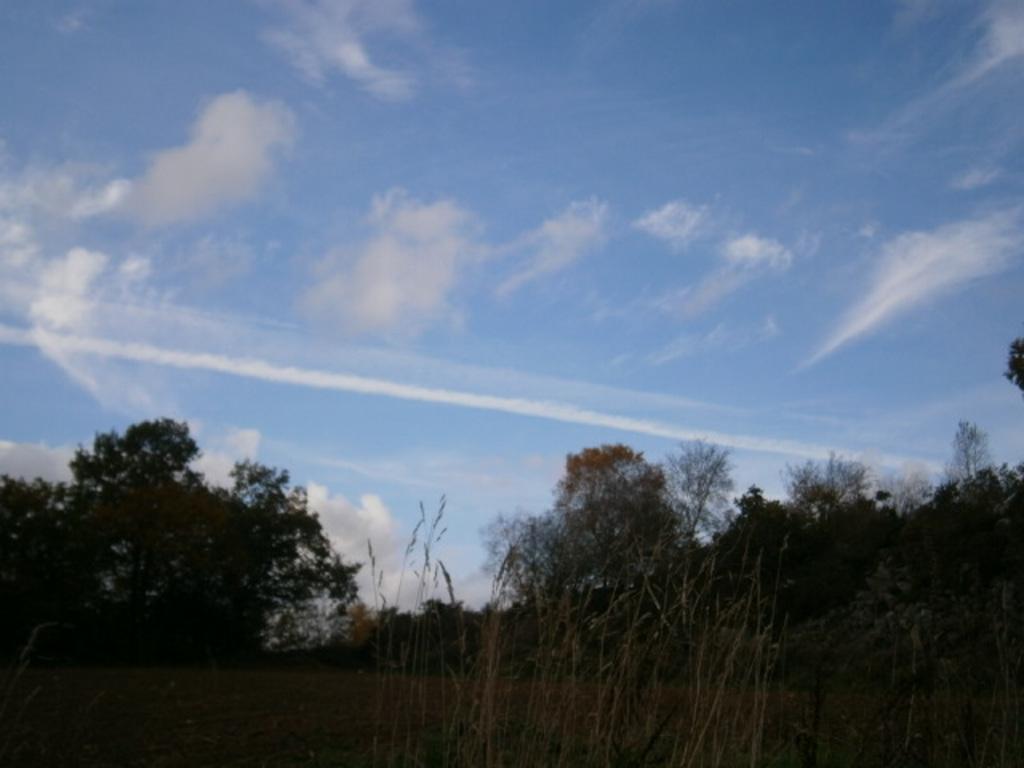Describe this image in one or two sentences. In this picture there are trees at the bottom side of the image and there is sky at the top side of the image. 